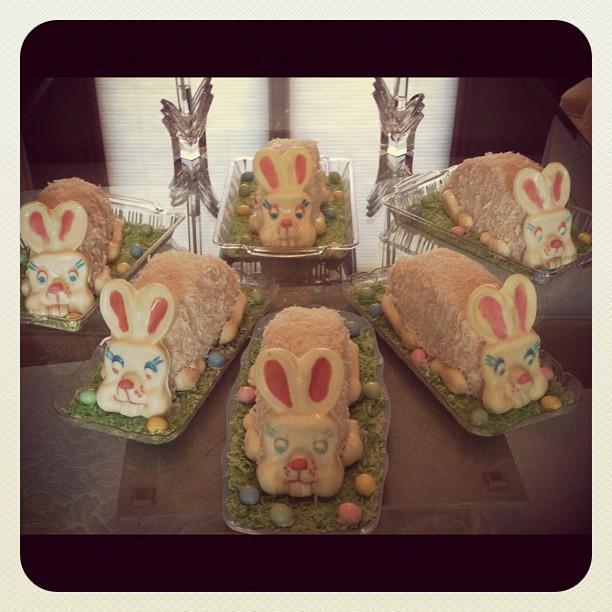What kind of animals are these cakes prepared to the shape of?
Select the accurate response from the four choices given to answer the question.
Options: Fox, hound, rabbit, penguin. Rabbit. 